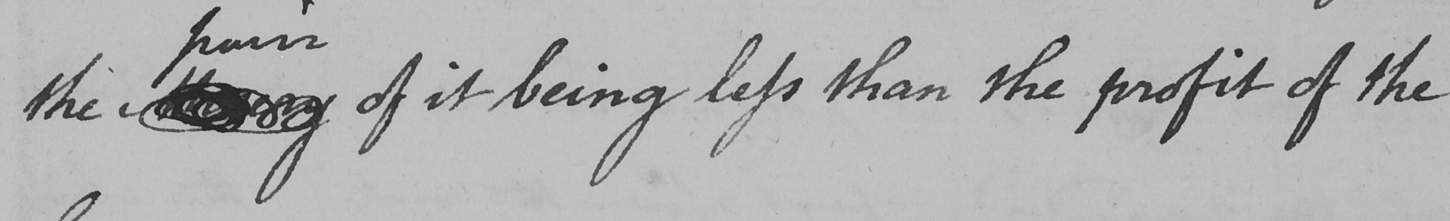What does this handwritten line say? the Misery of it being less than the profit of the 